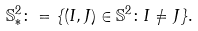<formula> <loc_0><loc_0><loc_500><loc_500>\mathbb { S } ^ { 2 } _ { * } \colon = \{ ( I , J ) \in \mathbb { S } ^ { 2 } \colon I \neq J \} .</formula> 